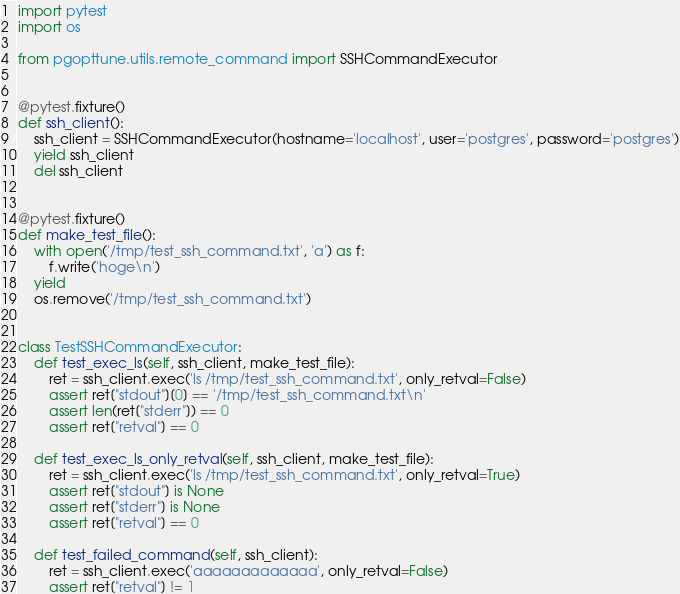Convert code to text. <code><loc_0><loc_0><loc_500><loc_500><_Python_>import pytest
import os

from pgopttune.utils.remote_command import SSHCommandExecutor


@pytest.fixture()
def ssh_client():
    ssh_client = SSHCommandExecutor(hostname='localhost', user='postgres', password='postgres')
    yield ssh_client
    del ssh_client


@pytest.fixture()
def make_test_file():
    with open('/tmp/test_ssh_command.txt', 'a') as f:
        f.write('hoge\n')
    yield
    os.remove('/tmp/test_ssh_command.txt')


class TestSSHCommandExecutor:
    def test_exec_ls(self, ssh_client, make_test_file):
        ret = ssh_client.exec('ls /tmp/test_ssh_command.txt', only_retval=False)
        assert ret["stdout"][0] == '/tmp/test_ssh_command.txt\n'
        assert len(ret["stderr"]) == 0
        assert ret["retval"] == 0

    def test_exec_ls_only_retval(self, ssh_client, make_test_file):
        ret = ssh_client.exec('ls /tmp/test_ssh_command.txt', only_retval=True)
        assert ret["stdout"] is None
        assert ret["stderr"] is None
        assert ret["retval"] == 0

    def test_failed_command(self, ssh_client):
        ret = ssh_client.exec('aaaaaaaaaaaaa', only_retval=False)
        assert ret["retval"] != 1
</code> 